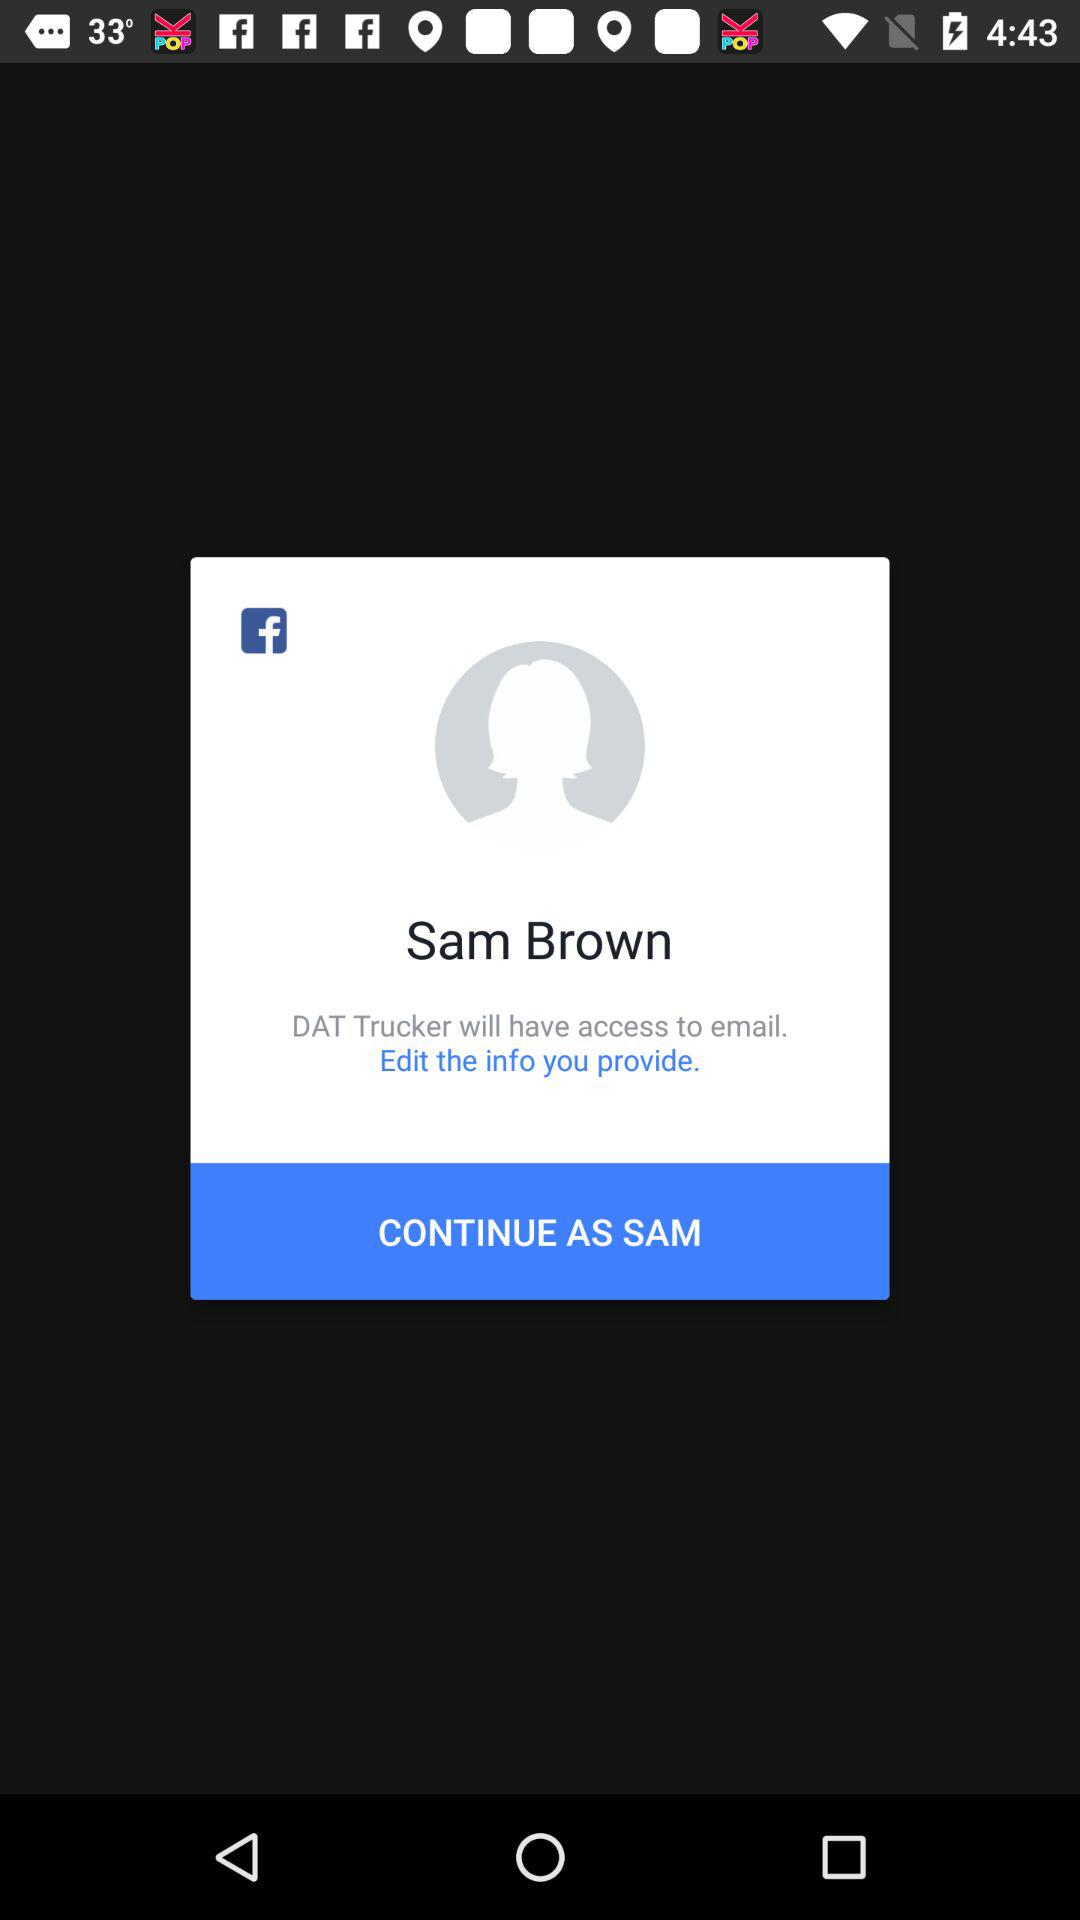What account am I using to continue? You are using your "Facebook" account. 